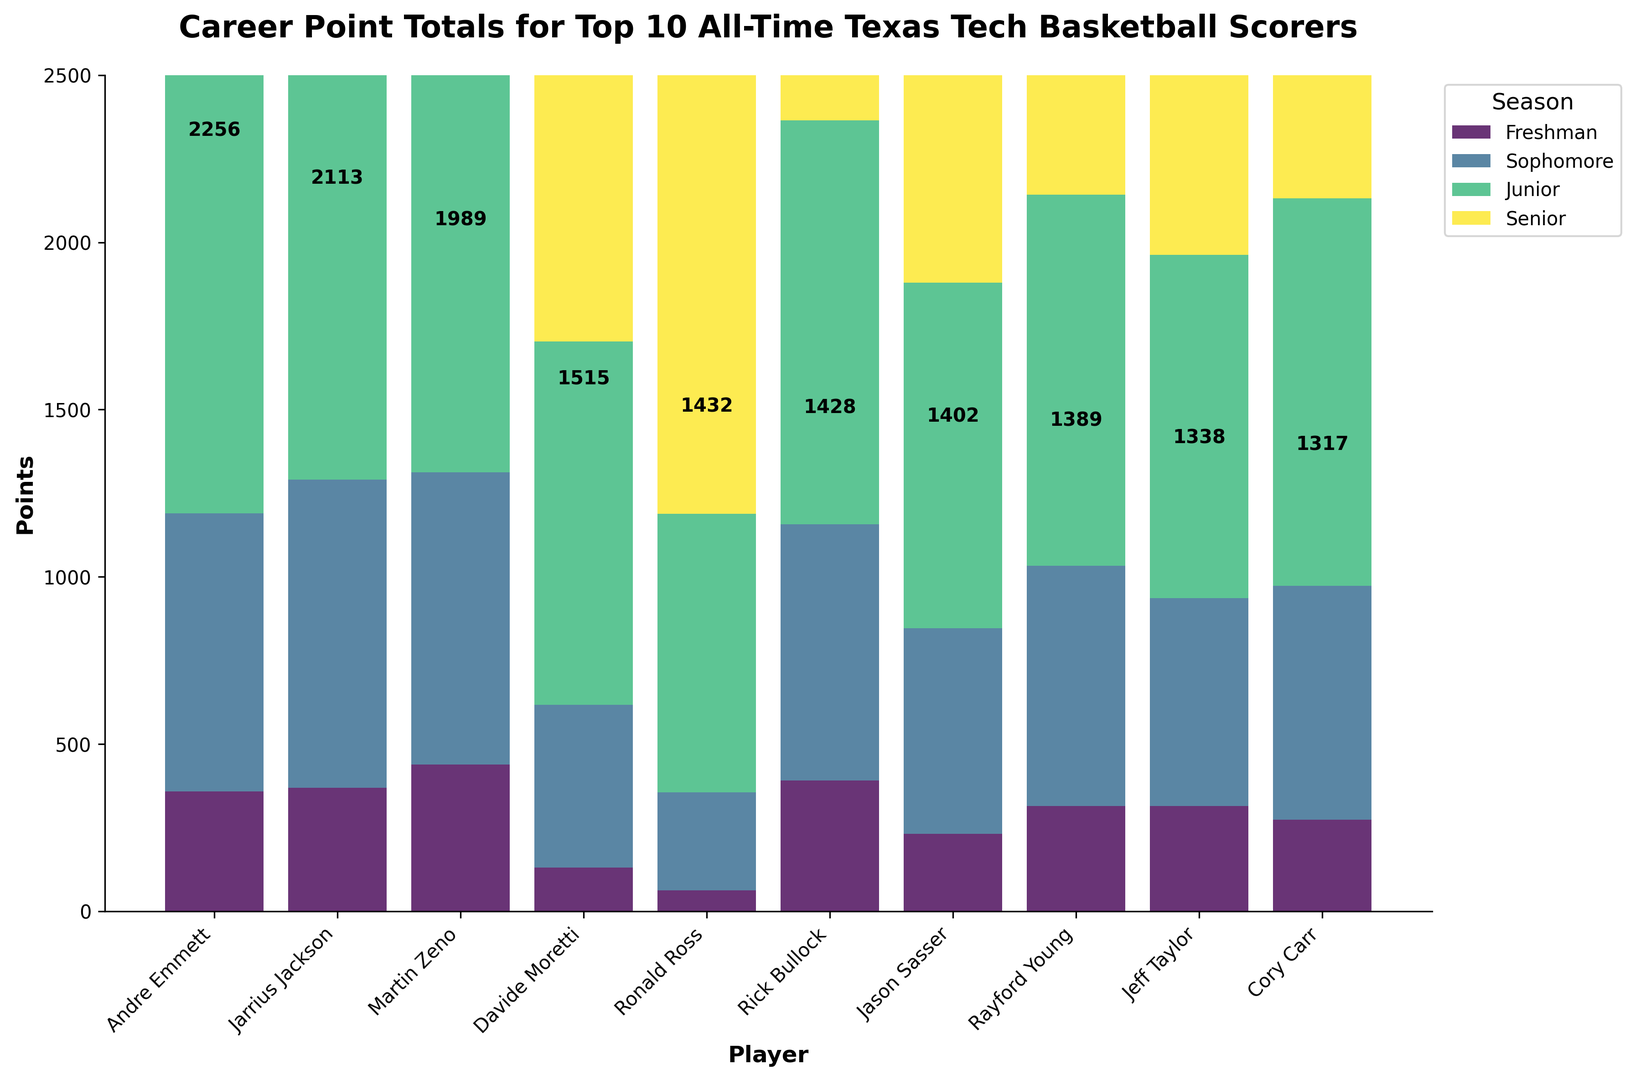What is the total number of points scored by Andre Emmett throughout his career? The figure shows the total points for each player at the top of their respective bars. Andre Emmett's bar has the number 2256 written above it.
Answer: 2256 Which player scored the most points in their Freshman year? In the plot, look at the bottom segments of each bar which represent Freshman year points. The player with the highest lower segment is Martin Zeno with 439 points.
Answer: Martin Zeno Who scored more points during their Sophomore year, Jarrius Jackson or Martin Zeno? Compare the second segments of the bars for Jarrius Jackson and Martin Zeno. Jarrius Jackson scored 922 points, while Martin Zeno scored 874 points.
Answer: Jarrius Jackson Which player accumulated the highest total points overall? By comparing the heights of all the bars and the numbers at the top, Andre Emmett scored the highest total points with 2256.
Answer: Andre Emmett What is the sum of the points scored by the top 3 players in their Junior years? The three top players in terms of total points are Andre Emmett (1431), Jarrius Jackson (1545), and Martin Zeno (1406). Summing the Junior year points for these three gives 1431 + 1545 + 1406 = 4382.
Answer: 4382 Which season contributed the least to Davide Moretti's total points? In the figure, look for the smallest segment in Davide Moretti's bar. The Freshman year segment is the smallest, with 131 points.
Answer: Freshman During their Senior years, did Jason Sasser score more points than Cory Carr? Compare the fourth segments of the bars for Jason Sasser and Cory Carr. Jason Sasser scored 1402 points, while Cory Carr scored 1317 points.
Answer: Yes Which two players have the closest total career points? To find the closest values, compare the total points written above each bar. Jeff Taylor (1338) and Cory Carr (1317) have the closest total career points, with a difference of 21 points.
Answer: Jeff Taylor and Cory Carr How many players scored over 2000 points in their careers? Read the figures at the top of each bar and count the players with totals above 2000. Andre Emmett with 2256 points and Jarrius Jackson with 2113 points are the only two.
Answer: 2 